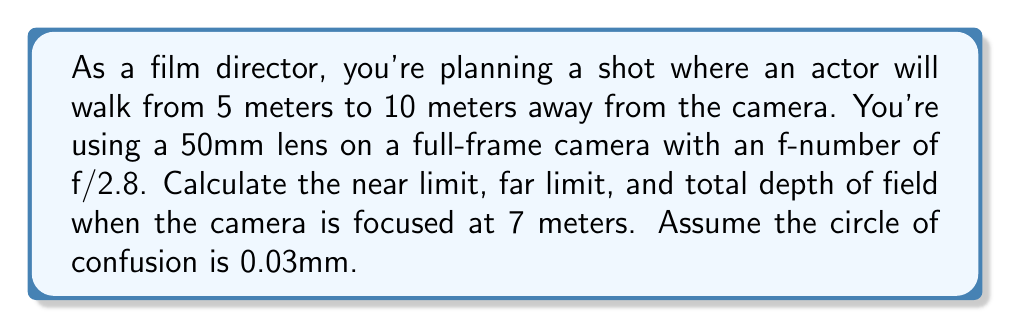Help me with this question. To solve this problem, we'll use the depth of field equations and follow these steps:

1. Calculate the hyperfocal distance:
   $$H = \frac{f^2}{N \cdot c} + f$$
   where $f$ is the focal length, $N$ is the f-number, and $c$ is the circle of confusion.
   
   $$H = \frac{50^2}{2.8 \cdot 0.03} + 50 = 29,761.90 \text{ mm} \approx 29.76 \text{ m}$$

2. Calculate the near limit of the depth of field:
   $$D_n = \frac{s \cdot (H - f)}{H + s - 2f}$$
   where $s$ is the focus distance.
   
   $$D_n = \frac{7000 \cdot (29761.90 - 50)}{29761.90 + 7000 - 2(50)} = 5,833.33 \text{ mm} \approx 5.83 \text{ m}$$

3. Calculate the far limit of the depth of field:
   $$D_f = \frac{s \cdot (H - f)}{H - s}$$
   
   $$D_f = \frac{7000 \cdot (29761.90 - 50)}{29761.90 - 7000} = 8,750 \text{ mm} = 8.75 \text{ m}$$

4. Calculate the total depth of field:
   Total DoF = Far limit - Near limit
   $$\text{Total DoF} = 8.75 - 5.83 = 2.92 \text{ m}$$
Answer: Near limit: 5.83 m, Far limit: 8.75 m, Total depth of field: 2.92 m 